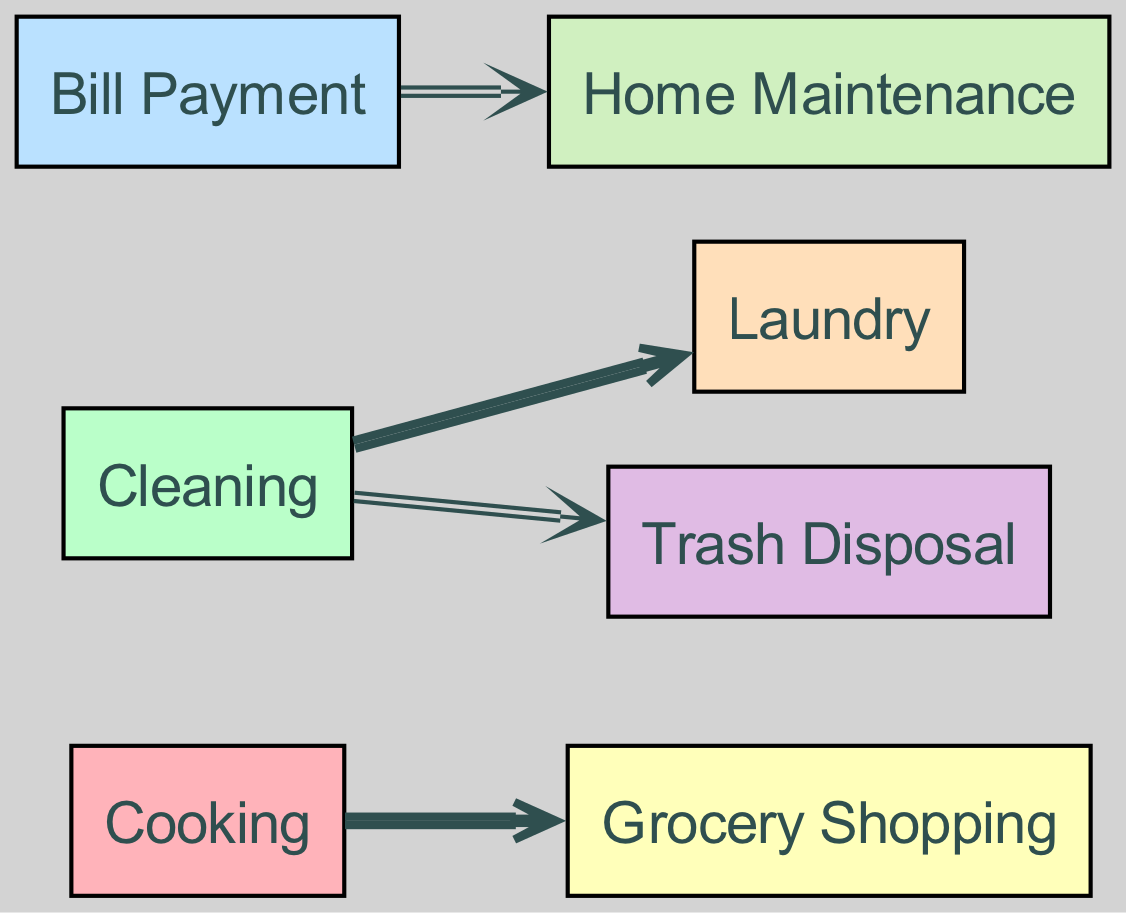What household task has the highest value linked to it? By examining the values assigned to the links, we see that "Cooking" has a value of 2 associated with "Grocery Shopping" and "Cleaning" also has a value of 2 linked to "Laundry." There is no other task with a higher value.
Answer: Cooking and Cleaning How many total tasks are represented in the diagram? The diagram features a total of 7 nodes, representing different household tasks such as Cooking, Cleaning, Bill Payment, Grocery Shopping, Laundry, Trash Disposal, and Home Maintenance.
Answer: 7 Which task is associated with the least number of responsibilities? The task "Bill Payment" has only one link associated with it, which connects to "Home Maintenance." This makes it the task with the least responsibilities in the diagram.
Answer: Bill Payment What is the total value of links originating from the "Cleaning" task? The value of the links originating from "Cleaning" includes 2 for "Laundry" and 1 for "Trash Disposal." Adding these values gives a total of 2 + 1 = 3.
Answer: 3 Which task has a direct link to "Grocery Shopping"? The task "Cooking" is directly linked to "Grocery Shopping," indicating that it is responsible for that specific task in the household division.
Answer: Cooking What is the average value of the links in the diagram? There are 4 links in total with values 2, 2, 1, and 1. The sum of these values is 6, and dividing by the number of links (4) gives an average value of 6 / 4 = 1.5.
Answer: 1.5 Which two tasks share the same value of 2 in the diagram? The tasks "Cooking" and "Cleaning" both have a value of 2 associated with them, indicating that they have equal levels of responsibility in this presentation.
Answer: Cooking and Cleaning What relationship does "Bill Payment" have with "Home Maintenance"? "Bill Payment" is directly linked to "Home Maintenance," signifying that it plays a role in supporting the home in terms of maintenance through financial responsibilities.
Answer: A direct link 